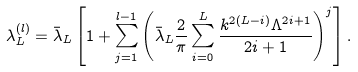<formula> <loc_0><loc_0><loc_500><loc_500>\lambda _ { L } ^ { ( l ) } = \bar { \lambda } _ { L } \left [ 1 + \sum _ { j = 1 } ^ { l - 1 } \left ( \bar { \lambda } _ { L } \frac { 2 } { \pi } \sum _ { i = 0 } ^ { L } \frac { k ^ { 2 ( L - i ) } \Lambda ^ { 2 i + 1 } } { 2 i + 1 } \right ) ^ { j } \right ] .</formula> 